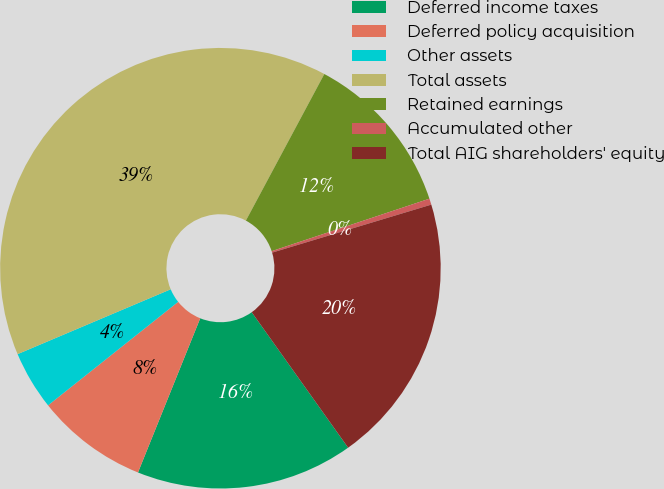<chart> <loc_0><loc_0><loc_500><loc_500><pie_chart><fcel>Deferred income taxes<fcel>Deferred policy acquisition<fcel>Other assets<fcel>Total assets<fcel>Retained earnings<fcel>Accumulated other<fcel>Total AIG shareholders' equity<nl><fcel>15.95%<fcel>8.2%<fcel>4.32%<fcel>39.2%<fcel>12.07%<fcel>0.45%<fcel>19.82%<nl></chart> 